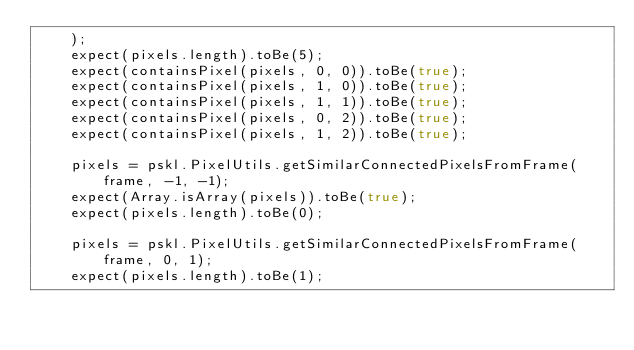Convert code to text. <code><loc_0><loc_0><loc_500><loc_500><_JavaScript_>    );
    expect(pixels.length).toBe(5);
    expect(containsPixel(pixels, 0, 0)).toBe(true);
    expect(containsPixel(pixels, 1, 0)).toBe(true);
    expect(containsPixel(pixels, 1, 1)).toBe(true);
    expect(containsPixel(pixels, 0, 2)).toBe(true);
    expect(containsPixel(pixels, 1, 2)).toBe(true);

    pixels = pskl.PixelUtils.getSimilarConnectedPixelsFromFrame(frame, -1, -1);
    expect(Array.isArray(pixels)).toBe(true);
    expect(pixels.length).toBe(0);

    pixels = pskl.PixelUtils.getSimilarConnectedPixelsFromFrame(frame, 0, 1);
    expect(pixels.length).toBe(1);</code> 